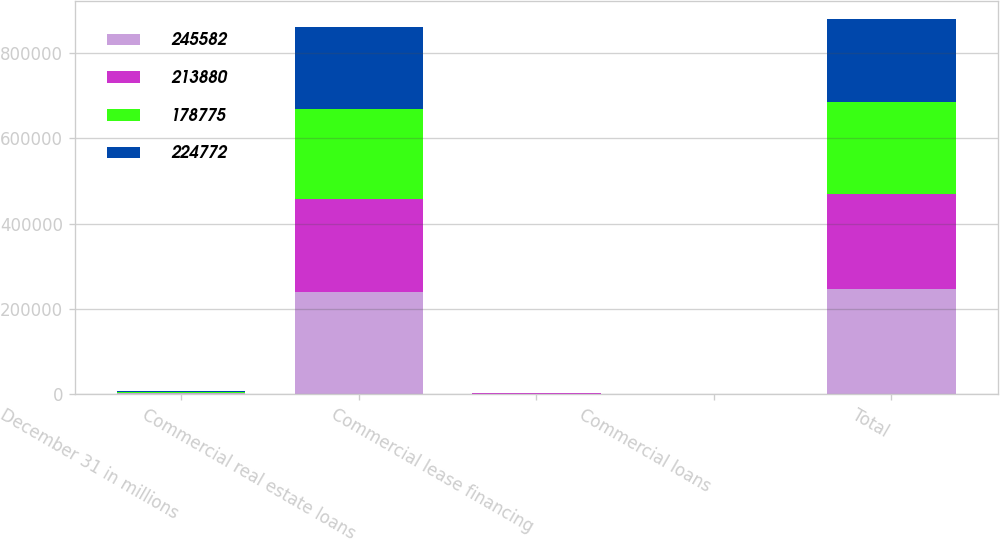<chart> <loc_0><loc_0><loc_500><loc_500><stacked_bar_chart><ecel><fcel>December 31 in millions<fcel>Commercial real estate loans<fcel>Commercial lease financing<fcel>Commercial loans<fcel>Total<nl><fcel>245582<fcel>2017<fcel>238718<fcel>862<fcel>488<fcel>245582<nl><fcel>213880<fcel>2016<fcel>218135<fcel>899<fcel>418<fcel>224772<nl><fcel>178775<fcel>2015<fcel>211274<fcel>932<fcel>335<fcel>213880<nl><fcel>224772<fcel>2014<fcel>191407<fcel>722<fcel>344<fcel>194062<nl></chart> 